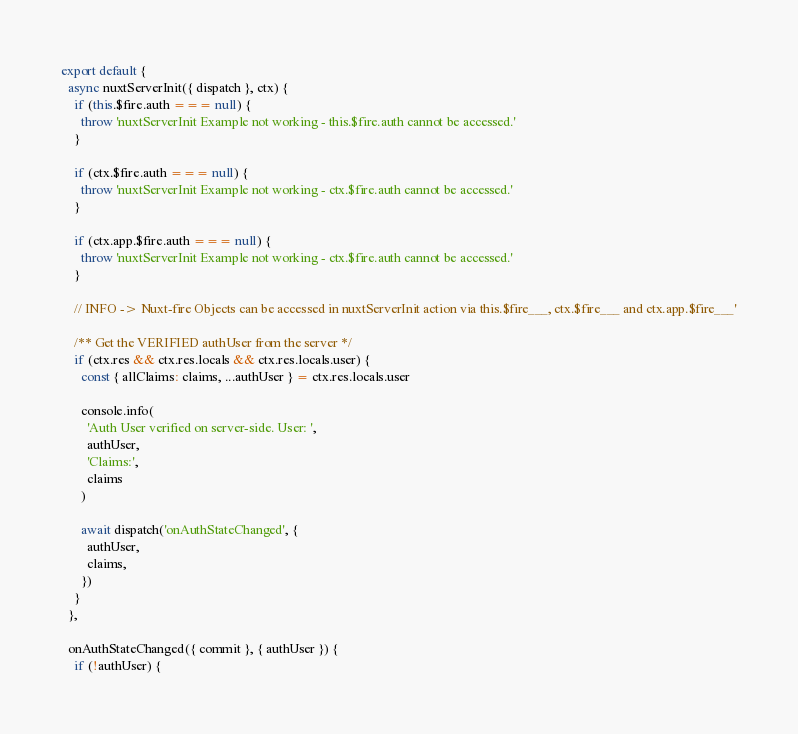<code> <loc_0><loc_0><loc_500><loc_500><_JavaScript_>export default {
  async nuxtServerInit({ dispatch }, ctx) {
    if (this.$fire.auth === null) {
      throw 'nuxtServerInit Example not working - this.$fire.auth cannot be accessed.'
    }

    if (ctx.$fire.auth === null) {
      throw 'nuxtServerInit Example not working - ctx.$fire.auth cannot be accessed.'
    }

    if (ctx.app.$fire.auth === null) {
      throw 'nuxtServerInit Example not working - ctx.$fire.auth cannot be accessed.'
    }

    // INFO -> Nuxt-fire Objects can be accessed in nuxtServerInit action via this.$fire___, ctx.$fire___ and ctx.app.$fire___'

    /** Get the VERIFIED authUser from the server */
    if (ctx.res && ctx.res.locals && ctx.res.locals.user) {
      const { allClaims: claims, ...authUser } = ctx.res.locals.user

      console.info(
        'Auth User verified on server-side. User: ',
        authUser,
        'Claims:',
        claims
      )

      await dispatch('onAuthStateChanged', {
        authUser,
        claims,
      })
    }
  },

  onAuthStateChanged({ commit }, { authUser }) {
    if (!authUser) {</code> 